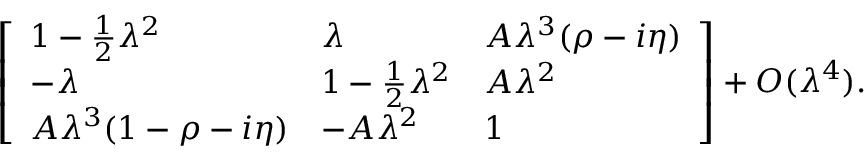Convert formula to latex. <formula><loc_0><loc_0><loc_500><loc_500>{ \left [ \begin{array} { l l l } { 1 - { \frac { 1 } { 2 } } \lambda ^ { 2 } } & { \lambda } & { A \lambda ^ { 3 } ( \rho - i \eta ) } \\ { - \lambda } & { 1 - { \frac { 1 } { 2 } } \lambda ^ { 2 } } & { A \lambda ^ { 2 } } \\ { A \lambda ^ { 3 } ( 1 - \rho - i \eta ) } & { - A \lambda ^ { 2 } } & { 1 } \end{array} \right ] } + O ( \lambda ^ { 4 } ) .</formula> 